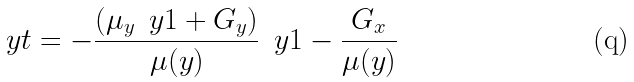Convert formula to latex. <formula><loc_0><loc_0><loc_500><loc_500>\ y t = - { \frac { ( \mu _ { y } \, \ y 1 + { G _ { y } } ) } { \mu ( y ) } } \, { \ y 1 } - { \frac { G _ { x } } { \mu ( y ) } }</formula> 